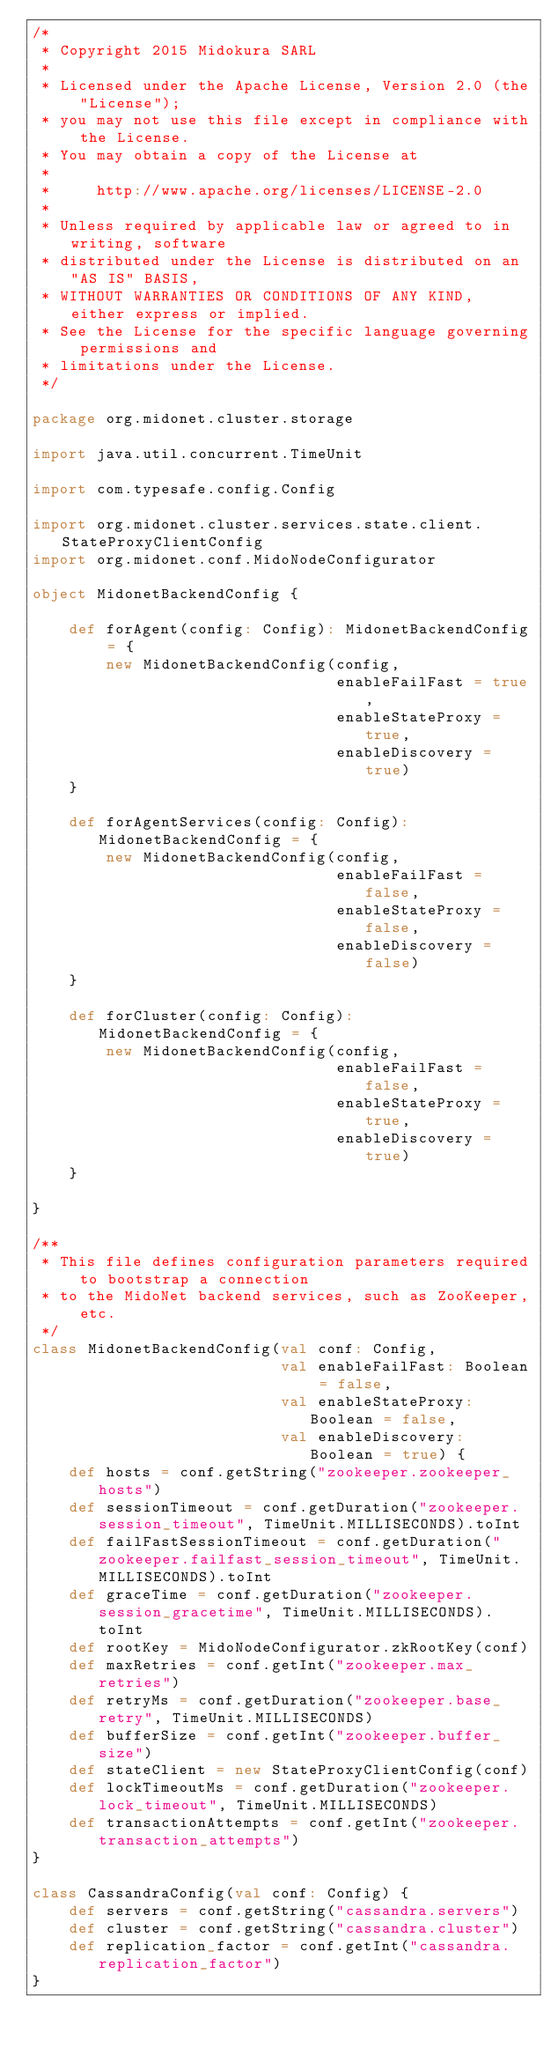<code> <loc_0><loc_0><loc_500><loc_500><_Scala_>/*
 * Copyright 2015 Midokura SARL
 *
 * Licensed under the Apache License, Version 2.0 (the "License");
 * you may not use this file except in compliance with the License.
 * You may obtain a copy of the License at
 *
 *     http://www.apache.org/licenses/LICENSE-2.0
 *
 * Unless required by applicable law or agreed to in writing, software
 * distributed under the License is distributed on an "AS IS" BASIS,
 * WITHOUT WARRANTIES OR CONDITIONS OF ANY KIND, either express or implied.
 * See the License for the specific language governing permissions and
 * limitations under the License.
 */

package org.midonet.cluster.storage

import java.util.concurrent.TimeUnit

import com.typesafe.config.Config

import org.midonet.cluster.services.state.client.StateProxyClientConfig
import org.midonet.conf.MidoNodeConfigurator

object MidonetBackendConfig {

    def forAgent(config: Config): MidonetBackendConfig = {
        new MidonetBackendConfig(config,
                                 enableFailFast = true,
                                 enableStateProxy = true,
                                 enableDiscovery = true)
    }

    def forAgentServices(config: Config): MidonetBackendConfig = {
        new MidonetBackendConfig(config,
                                 enableFailFast = false,
                                 enableStateProxy = false,
                                 enableDiscovery = false)
    }

    def forCluster(config: Config): MidonetBackendConfig = {
        new MidonetBackendConfig(config,
                                 enableFailFast = false,
                                 enableStateProxy = true,
                                 enableDiscovery = true)
    }

}

/**
 * This file defines configuration parameters required to bootstrap a connection
 * to the MidoNet backend services, such as ZooKeeper, etc.
 */
class MidonetBackendConfig(val conf: Config,
                           val enableFailFast: Boolean = false,
                           val enableStateProxy: Boolean = false,
                           val enableDiscovery: Boolean = true) {
    def hosts = conf.getString("zookeeper.zookeeper_hosts")
    def sessionTimeout = conf.getDuration("zookeeper.session_timeout", TimeUnit.MILLISECONDS).toInt
    def failFastSessionTimeout = conf.getDuration("zookeeper.failfast_session_timeout", TimeUnit.MILLISECONDS).toInt
    def graceTime = conf.getDuration("zookeeper.session_gracetime", TimeUnit.MILLISECONDS).toInt
    def rootKey = MidoNodeConfigurator.zkRootKey(conf)
    def maxRetries = conf.getInt("zookeeper.max_retries")
    def retryMs = conf.getDuration("zookeeper.base_retry", TimeUnit.MILLISECONDS)
    def bufferSize = conf.getInt("zookeeper.buffer_size")
    def stateClient = new StateProxyClientConfig(conf)
    def lockTimeoutMs = conf.getDuration("zookeeper.lock_timeout", TimeUnit.MILLISECONDS)
    def transactionAttempts = conf.getInt("zookeeper.transaction_attempts")
}

class CassandraConfig(val conf: Config) {
    def servers = conf.getString("cassandra.servers")
    def cluster = conf.getString("cassandra.cluster")
    def replication_factor = conf.getInt("cassandra.replication_factor")
}
</code> 